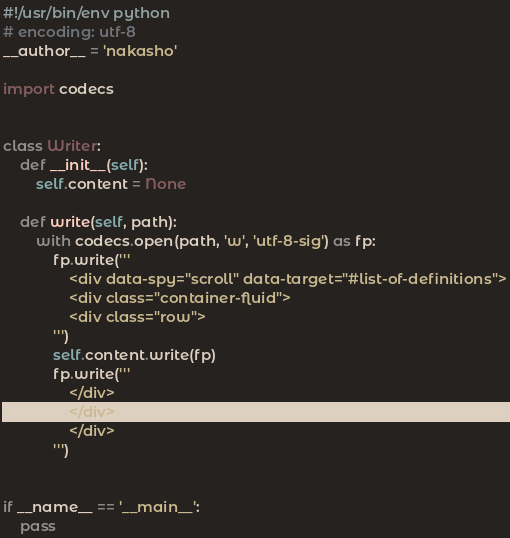Convert code to text. <code><loc_0><loc_0><loc_500><loc_500><_Python_>#!/usr/bin/env python
# encoding: utf-8
__author__ = 'nakasho'

import codecs


class Writer:
    def __init__(self):
        self.content = None

    def write(self, path):
        with codecs.open(path, 'w', 'utf-8-sig') as fp:
            fp.write('''
                <div data-spy="scroll" data-target="#list-of-definitions">
                <div class="container-fluid">
                <div class="row">
            ''')
            self.content.write(fp)
            fp.write('''
                </div>
                </div>
                </div>
            ''')


if __name__ == '__main__':
    pass
</code> 